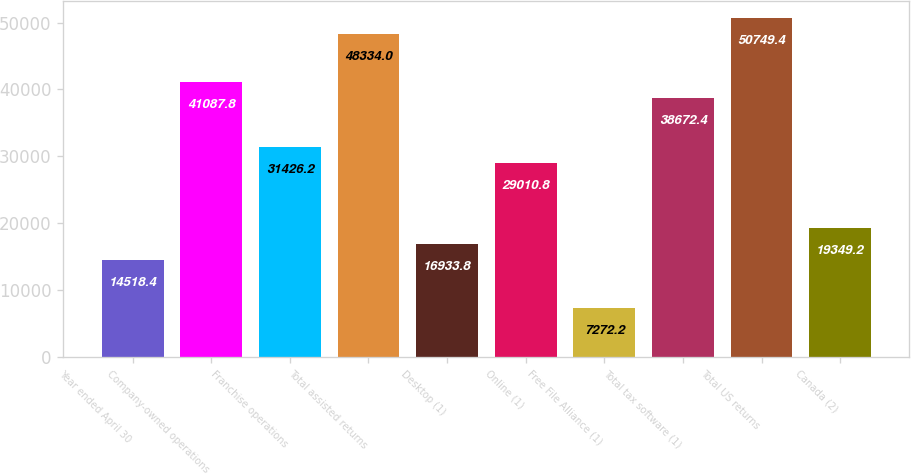Convert chart. <chart><loc_0><loc_0><loc_500><loc_500><bar_chart><fcel>Year ended April 30<fcel>Company-owned operations<fcel>Franchise operations<fcel>Total assisted returns<fcel>Desktop (1)<fcel>Online (1)<fcel>Free File Alliance (1)<fcel>Total tax software (1)<fcel>Total US returns<fcel>Canada (2)<nl><fcel>14518.4<fcel>41087.8<fcel>31426.2<fcel>48334<fcel>16933.8<fcel>29010.8<fcel>7272.2<fcel>38672.4<fcel>50749.4<fcel>19349.2<nl></chart> 